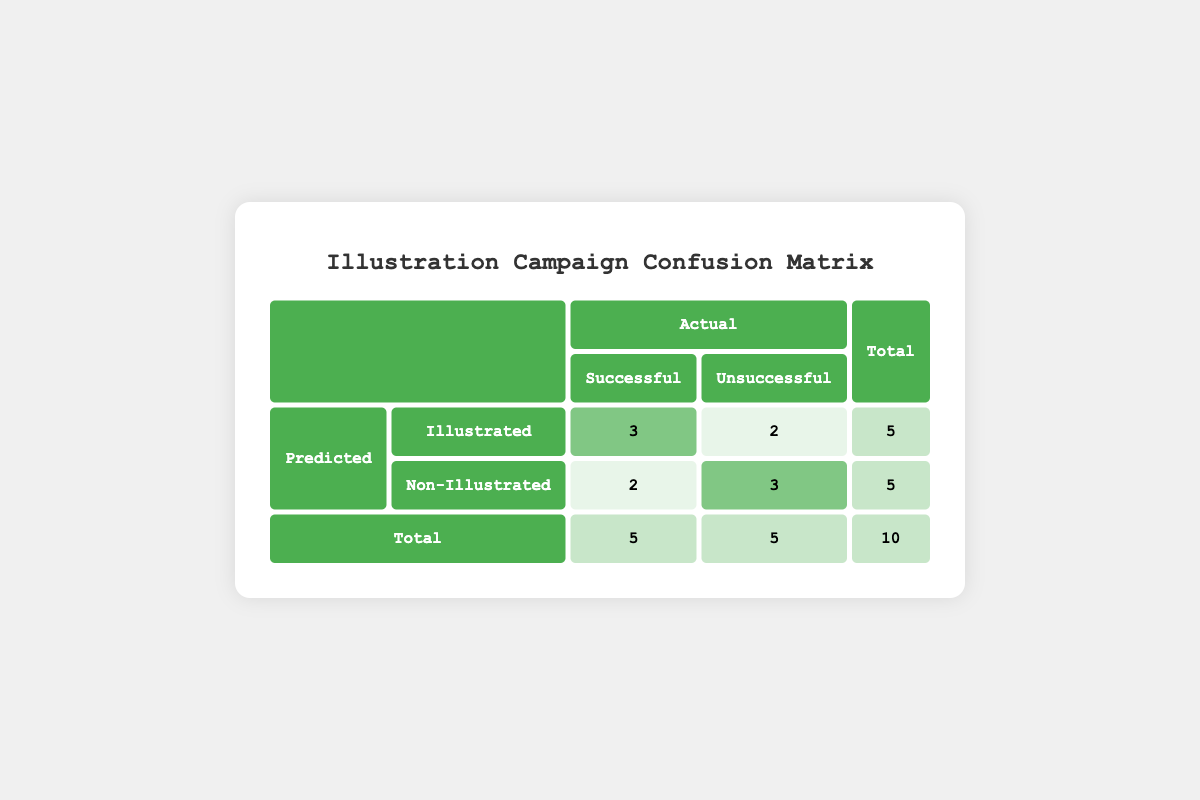What is the total number of campaigns that featured illustrations? In the matrix, we can see that the "Illustrated" row indicates a total of 5 campaigns. This is confirmed when adding the successful (3) and unsuccessful (2) outcomes under the illustrated category.
Answer: 5 How many campaigns in total were unsuccessful? The table shows 5 campaigns categorized as "Unsuccessful": 2 under "Illustrated" and 3 under "Non-Illustrated." Adding these gives us the total count of unsuccessful campaigns.
Answer: 5 What is the success rate for campaigns that included illustrations? The success rate can be calculated by taking the number of successful campaigns (3) out of total illustrated campaigns (5), so: (3/5) * 100% = 60%.
Answer: 60% Are there more successful non-illustrated campaigns than unsuccessful ones? The table shows that there are 2 successful non-illustrated campaigns and 3 unsuccessful ones. Therefore, it's true that there are more unsuccessful than successful campaigns in this category.
Answer: No What is the difference in the number of successful campaigns between illustrated and non-illustrated content? The number of successful illustrated campaigns is 3, and the number of successful non-illustrated campaigns is 2. The difference is: 3 - 2 = 1, indicating that illustrated campaigns had one more success than non-illustrated.
Answer: 1 How many total campaigns were successful? The total successful campaigns can be summed from both categories: 3 successful illustrated campaigns combined with 2 successful non-illustrated campaigns results in a total of 5 successful campaigns.
Answer: 5 Is the number of successful campaigns equal across both categories? The successful illustrated campaigns total 3, while the non-illustrated campaigns total 2. Since these numbers are not equal, the answer is no.
Answer: No What is the proportion of unsuccessful illustrated campaigns to the total number of campaigns? There are 2 unsuccessful illustrated campaigns out of a total of 10 campaigns. The proportion can be calculated as 2/10 = 0.2. This translates to a proportion of 0.2 or 20%.
Answer: 0.2 or 20% 